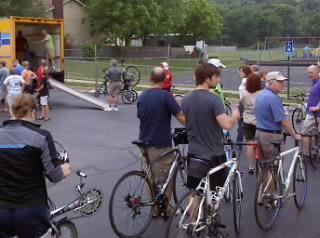Why might these people be lined up?
Select the accurate answer and provide explanation: 'Answer: answer
Rationale: rationale.'
Options: Repairs, race, lessons, donation. Answer: donation.
Rationale: The moving truck in the background suggests the bikes will be transported elsewhere. 